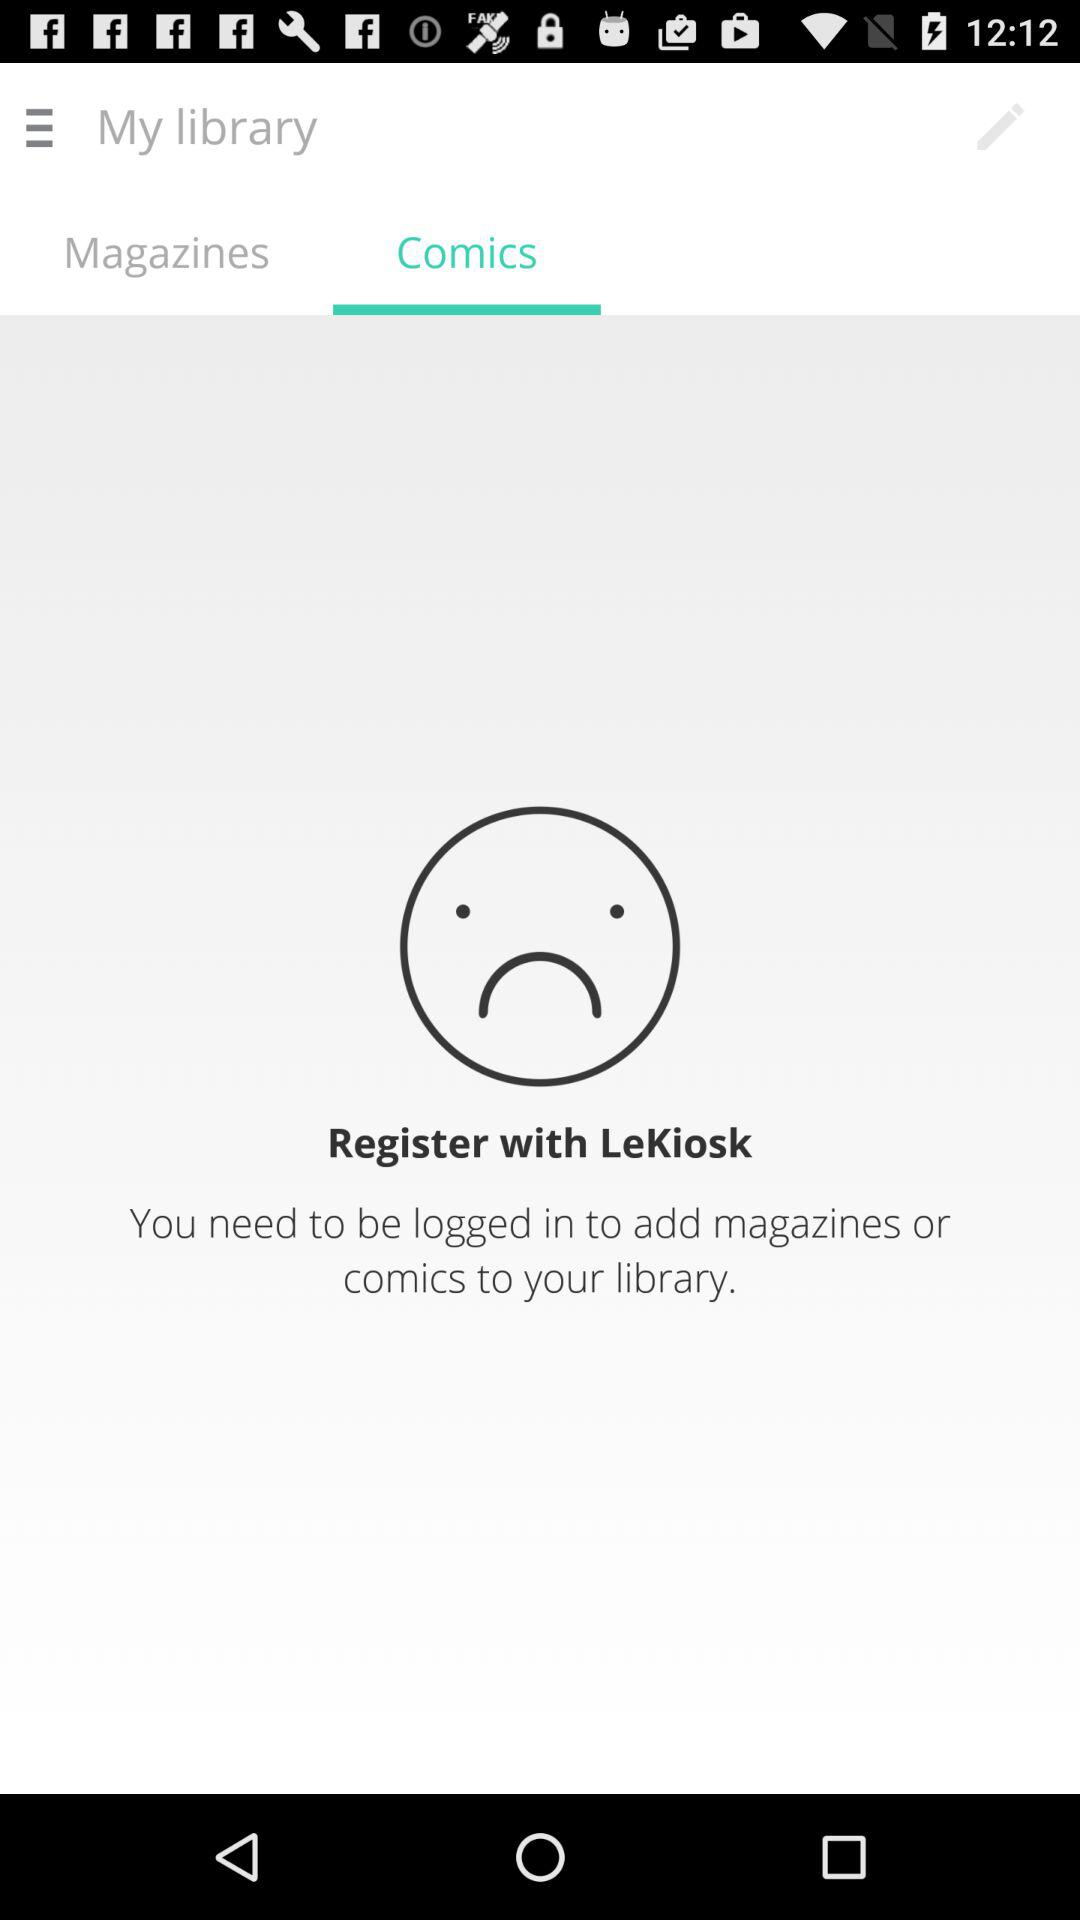Which tab is selected? The tab "Comics" is selected. 